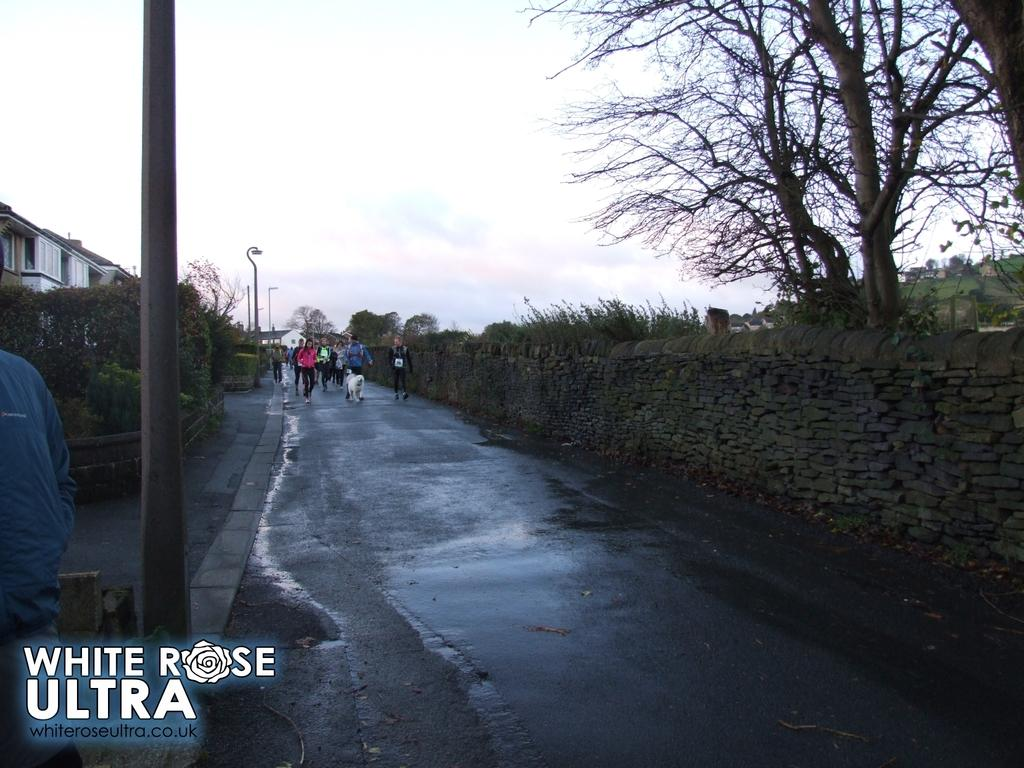Provide a one-sentence caption for the provided image. A group of people being led by a large white fluffy dog at teh White Rose Ultra marathon. 